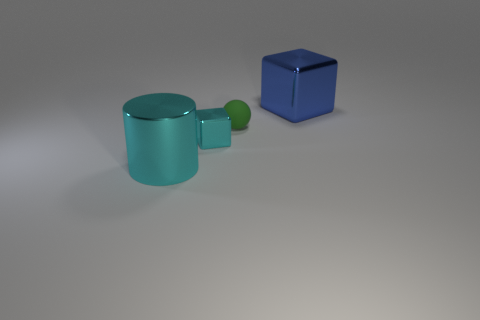Add 1 gray cubes. How many objects exist? 5 Subtract all blue cubes. How many cubes are left? 1 Subtract all spheres. How many objects are left? 3 Add 3 large metallic cylinders. How many large metallic cylinders are left? 4 Add 3 large things. How many large things exist? 5 Subtract 0 brown spheres. How many objects are left? 4 Subtract 2 blocks. How many blocks are left? 0 Subtract all yellow cylinders. Subtract all blue spheres. How many cylinders are left? 1 Subtract all green cylinders. How many cyan cubes are left? 1 Subtract all shiny objects. Subtract all tiny balls. How many objects are left? 0 